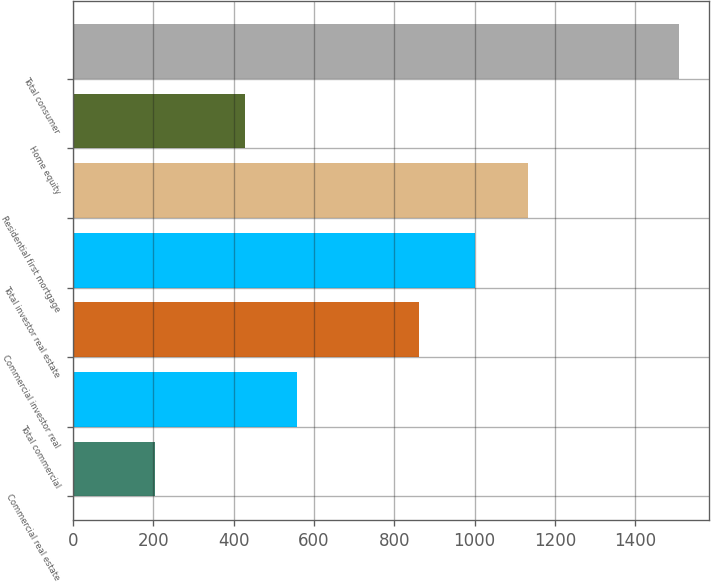Convert chart to OTSL. <chart><loc_0><loc_0><loc_500><loc_500><bar_chart><fcel>Commercial real estate<fcel>Total commercial<fcel>Commercial investor real<fcel>Total investor real estate<fcel>Residential first mortgage<fcel>Home equity<fcel>Total consumer<nl><fcel>205<fcel>558.4<fcel>862<fcel>1002<fcel>1132.4<fcel>428<fcel>1509<nl></chart> 